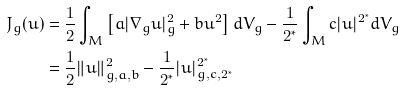Convert formula to latex. <formula><loc_0><loc_0><loc_500><loc_500>J _ { g } ( u ) & = \frac { 1 } { 2 } \int _ { M } \left [ a | \nabla _ { g } u | _ { g } ^ { 2 } + b u ^ { 2 } \right ] d V _ { g } - \frac { 1 } { 2 ^ { \ast } } \int _ { M } c | u | ^ { 2 ^ { \ast } } d V _ { g } \\ & = \frac { 1 } { 2 } \| u \| _ { g , a , b } ^ { 2 } - \frac { 1 } { 2 ^ { \ast } } | u | _ { g , c , 2 ^ { \ast } } ^ { 2 ^ { \ast } }</formula> 